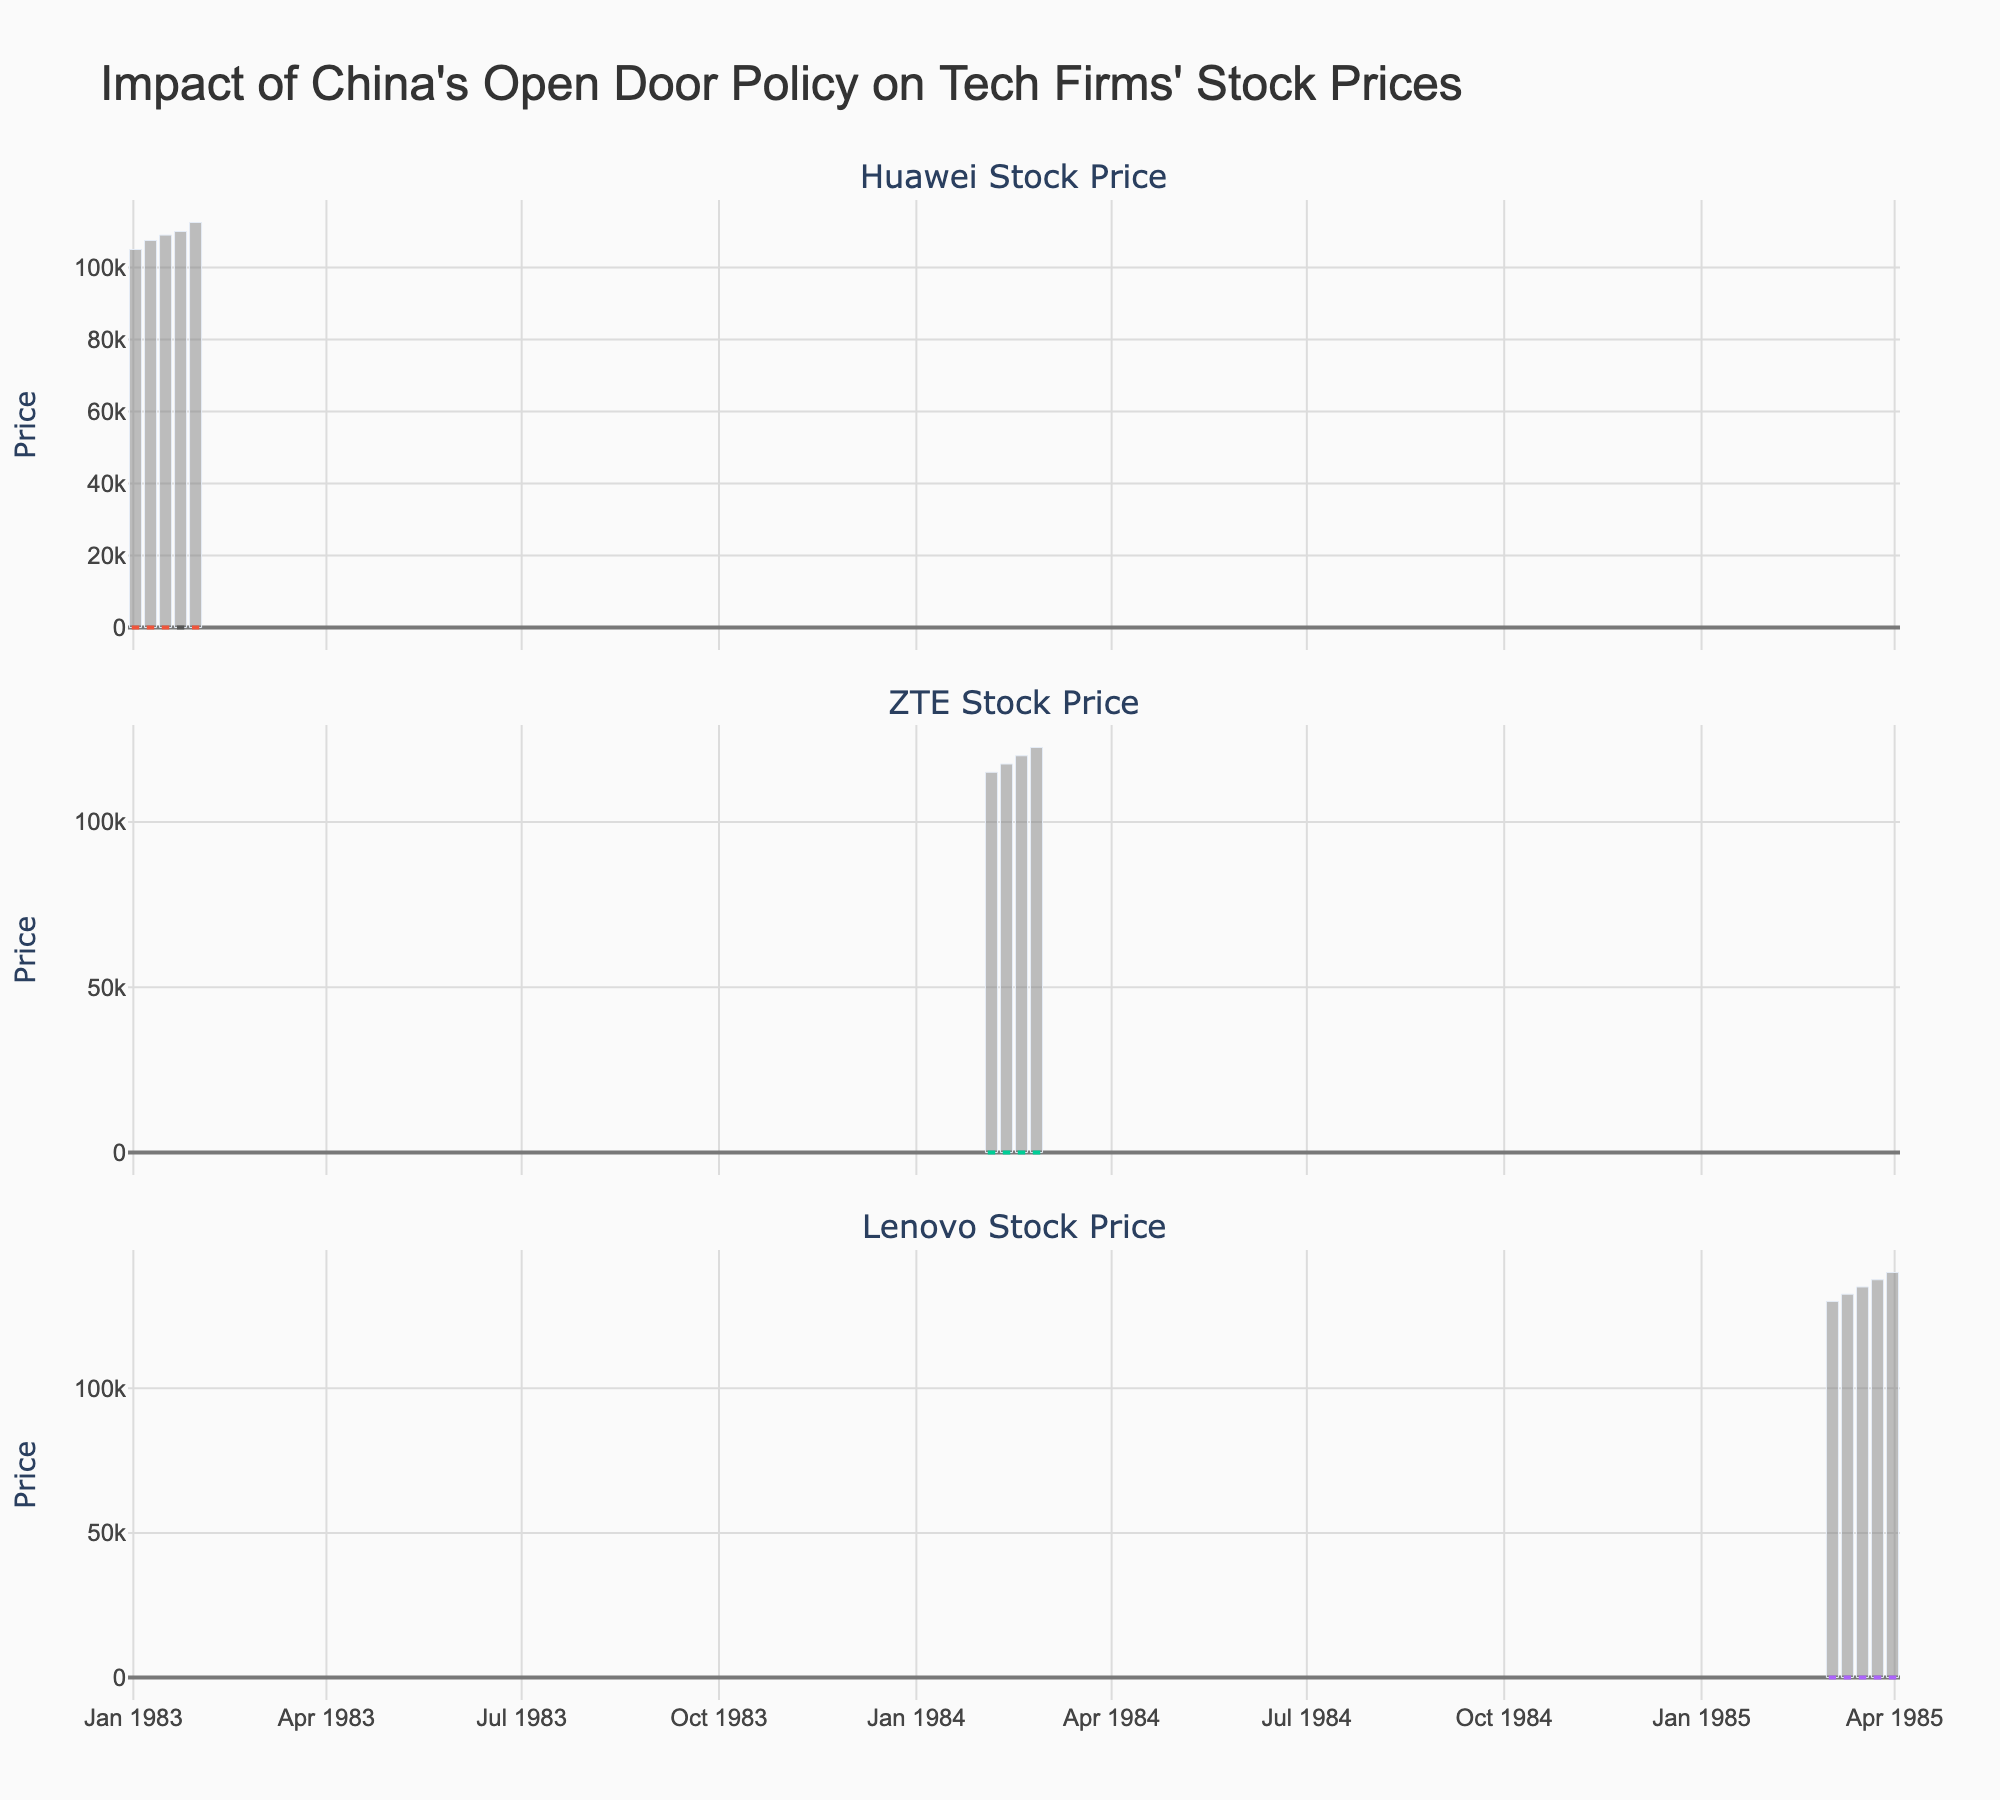How many data points are there for Huawei in the plot? The plot has multiple subplots, each representing a company with candlestick data. By counting the data points for the Huawei plot, we can determine the number. There are five data points for Huawei.
Answer: Five How does the stock price of Huawei from January 16, 1983, compare to January 23, 1983? On January 16, 1983, the closing price was 5.55, and on January 23, 1983, it was 5.35. Therefore, the closing price decreased from January 16 to January 23.
Answer: Decreased What is the title of the figure? The title is found at the top of the figure. It provides an overview of the subject matter depicted in the plot. The title is "Impact of China's Open Door Policy on Tech Firms' Stock Prices."
Answer: Impact of China's Open Door Policy on Tech Firms' Stock Prices Which company has the highest trading volume in any single week, and what is that volume? The subplot for each company includes volume data. By checking the volume bars for each week, we see that Lenovo has the highest trading volume of 140,000 on March 31, 1985.
Answer: Lenovo, 140,000 Compare the trend in stock prices for ZTE and Huawei during their respective periods. Which company shows a more consistent increase in stock prices? Analyzing the candlestick patterns for both companies during their periods can help us compare the trends. ZTE shows a more consistent increase from February 5, 1984, to February 26, 1984, while Huawei's stock prices show more fluctuations.
Answer: ZTE What is the average closing price for Lenovo over the period shown? The closing prices for Lenovo over the period are 8.60, 8.70, 8.85, 8.95, and 9.10. To find the average, sum these prices and divide by the number of data points: (8.60 + 8.70 + 8.85 + 8.95 + 9.10)/5 = 44.20/5 = 8.84.
Answer: 8.84 Between January 2, 1983, and January 16, 1983, did Huawei's stock price close higher or lower? Review the closing prices for Huawei on these dates: January 2, 1983, closed at 5.23, and January 16, 1983, closed at 5.55. The stock price closed higher on January 16, 1983, than on January 2, 1983.
Answer: Higher 